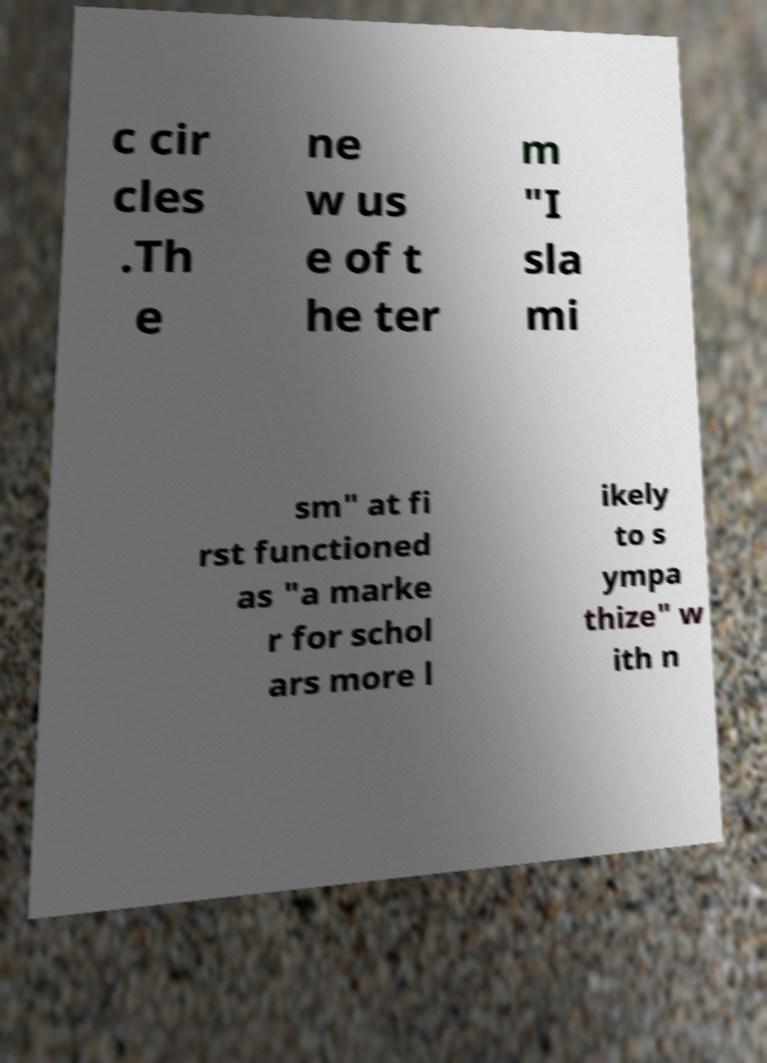Please read and relay the text visible in this image. What does it say? c cir cles .Th e ne w us e of t he ter m "I sla mi sm" at fi rst functioned as "a marke r for schol ars more l ikely to s ympa thize" w ith n 